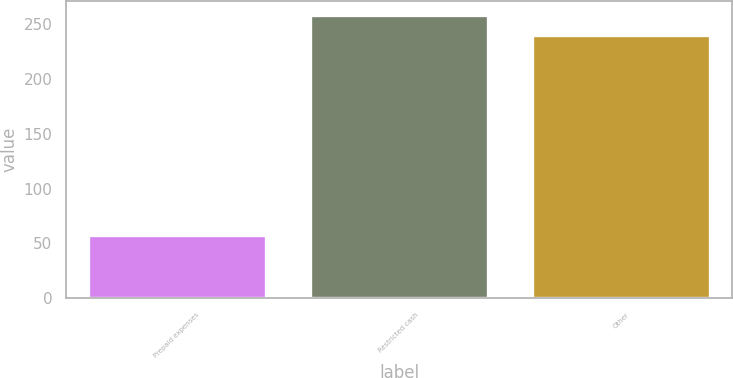<chart> <loc_0><loc_0><loc_500><loc_500><bar_chart><fcel>Prepaid expenses<fcel>Restricted cash<fcel>Other<nl><fcel>58<fcel>258.5<fcel>240<nl></chart> 